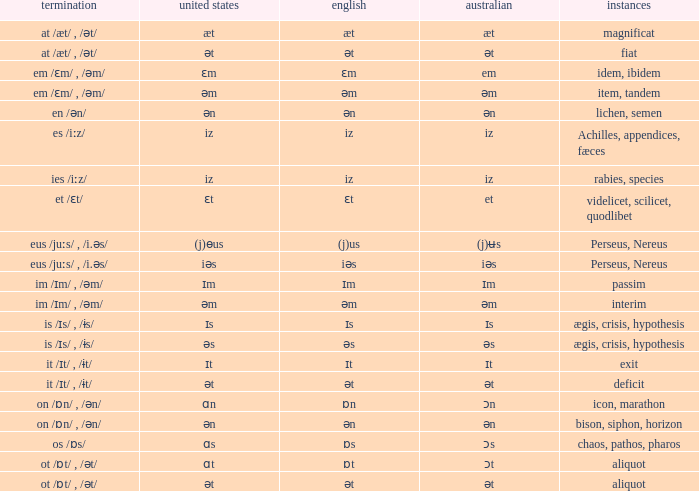In which british situations are there examples of leaving? Ɪt. 